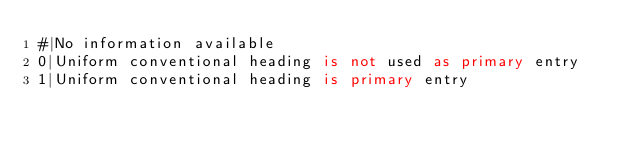Convert code to text. <code><loc_0><loc_0><loc_500><loc_500><_SQL_>#|No information available
0|Uniform conventional heading is not used as primary entry
1|Uniform conventional heading is primary entry</code> 